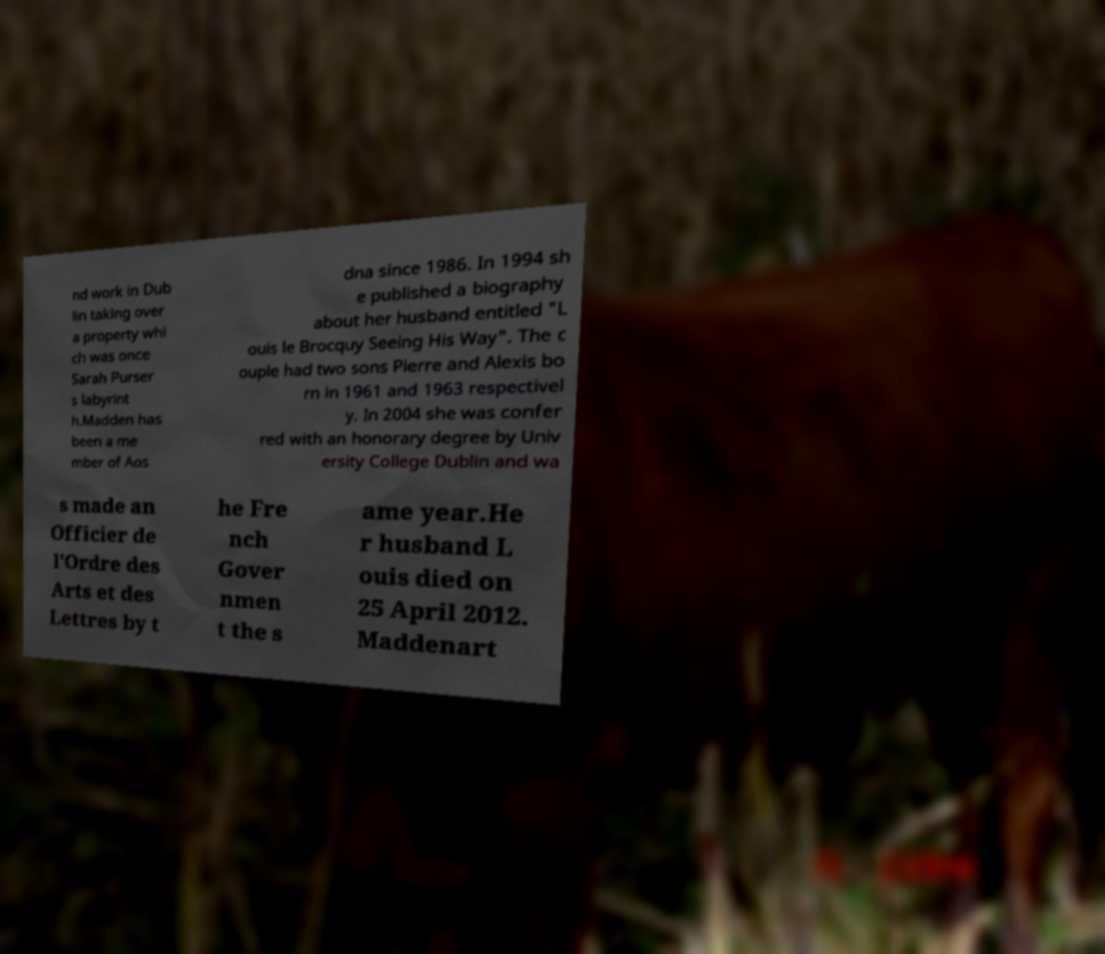For documentation purposes, I need the text within this image transcribed. Could you provide that? nd work in Dub lin taking over a property whi ch was once Sarah Purser s labyrint h.Madden has been a me mber of Aos dna since 1986. In 1994 sh e published a biography about her husband entitled "L ouis le Brocquy Seeing His Way". The c ouple had two sons Pierre and Alexis bo rn in 1961 and 1963 respectivel y. In 2004 she was confer red with an honorary degree by Univ ersity College Dublin and wa s made an Officier de l'Ordre des Arts et des Lettres by t he Fre nch Gover nmen t the s ame year.He r husband L ouis died on 25 April 2012. Maddenart 